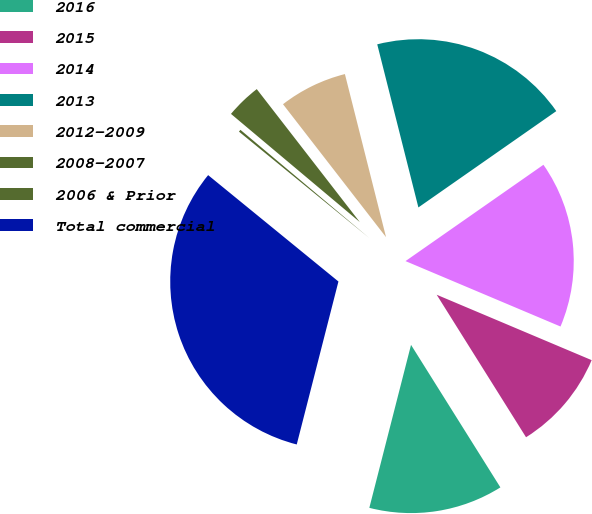<chart> <loc_0><loc_0><loc_500><loc_500><pie_chart><fcel>2016<fcel>2015<fcel>2014<fcel>2013<fcel>2012-2009<fcel>2008-2007<fcel>2006 & Prior<fcel>Total commercial<nl><fcel>12.9%<fcel>9.73%<fcel>16.06%<fcel>19.23%<fcel>6.56%<fcel>3.39%<fcel>0.22%<fcel>31.91%<nl></chart> 